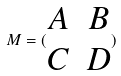<formula> <loc_0><loc_0><loc_500><loc_500>M = ( \begin{matrix} A & B \\ C & D \end{matrix} )</formula> 